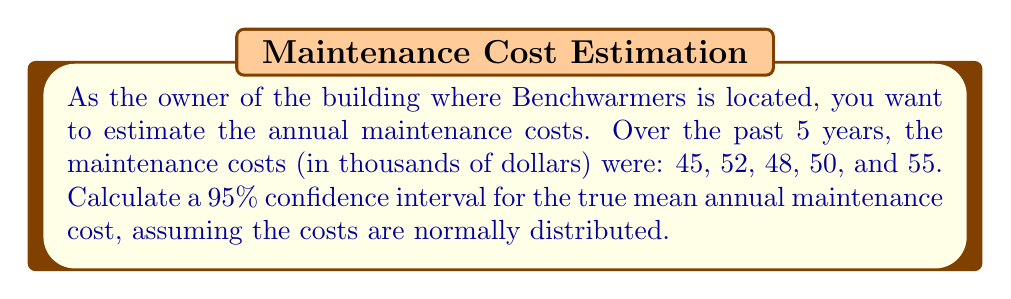Help me with this question. To calculate the confidence interval, we'll follow these steps:

1) Calculate the sample mean ($\bar{x}$):
   $$\bar{x} = \frac{45 + 52 + 48 + 50 + 55}{5} = 50$$

2) Calculate the sample standard deviation ($s$):
   $$s = \sqrt{\frac{\sum(x_i - \bar{x})^2}{n-1}} = \sqrt{\frac{(-5)^2 + 2^2 + (-2)^2 + 0^2 + 5^2}{4}} = 3.87$$

3) Determine the t-value for a 95% confidence interval with 4 degrees of freedom (n-1):
   $t_{0.025, 4} = 2.776$ (from t-distribution table)

4) Calculate the margin of error:
   $$\text{Margin of Error} = t_{0.025, 4} \cdot \frac{s}{\sqrt{n}} = 2.776 \cdot \frac{3.87}{\sqrt{5}} = 4.80$$

5) Compute the confidence interval:
   $$\text{CI} = \bar{x} \pm \text{Margin of Error} = 50 \pm 4.80$$
   
   Lower bound: $50 - 4.80 = 45.20$
   Upper bound: $50 + 4.80 = 54.80$

Therefore, the 95% confidence interval for the true mean annual maintenance cost is (45.20, 54.80) thousand dollars.
Answer: (45.20, 54.80) thousand dollars 